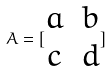<formula> <loc_0><loc_0><loc_500><loc_500>A = [ \begin{matrix} a & b \\ c & d \end{matrix} ]</formula> 